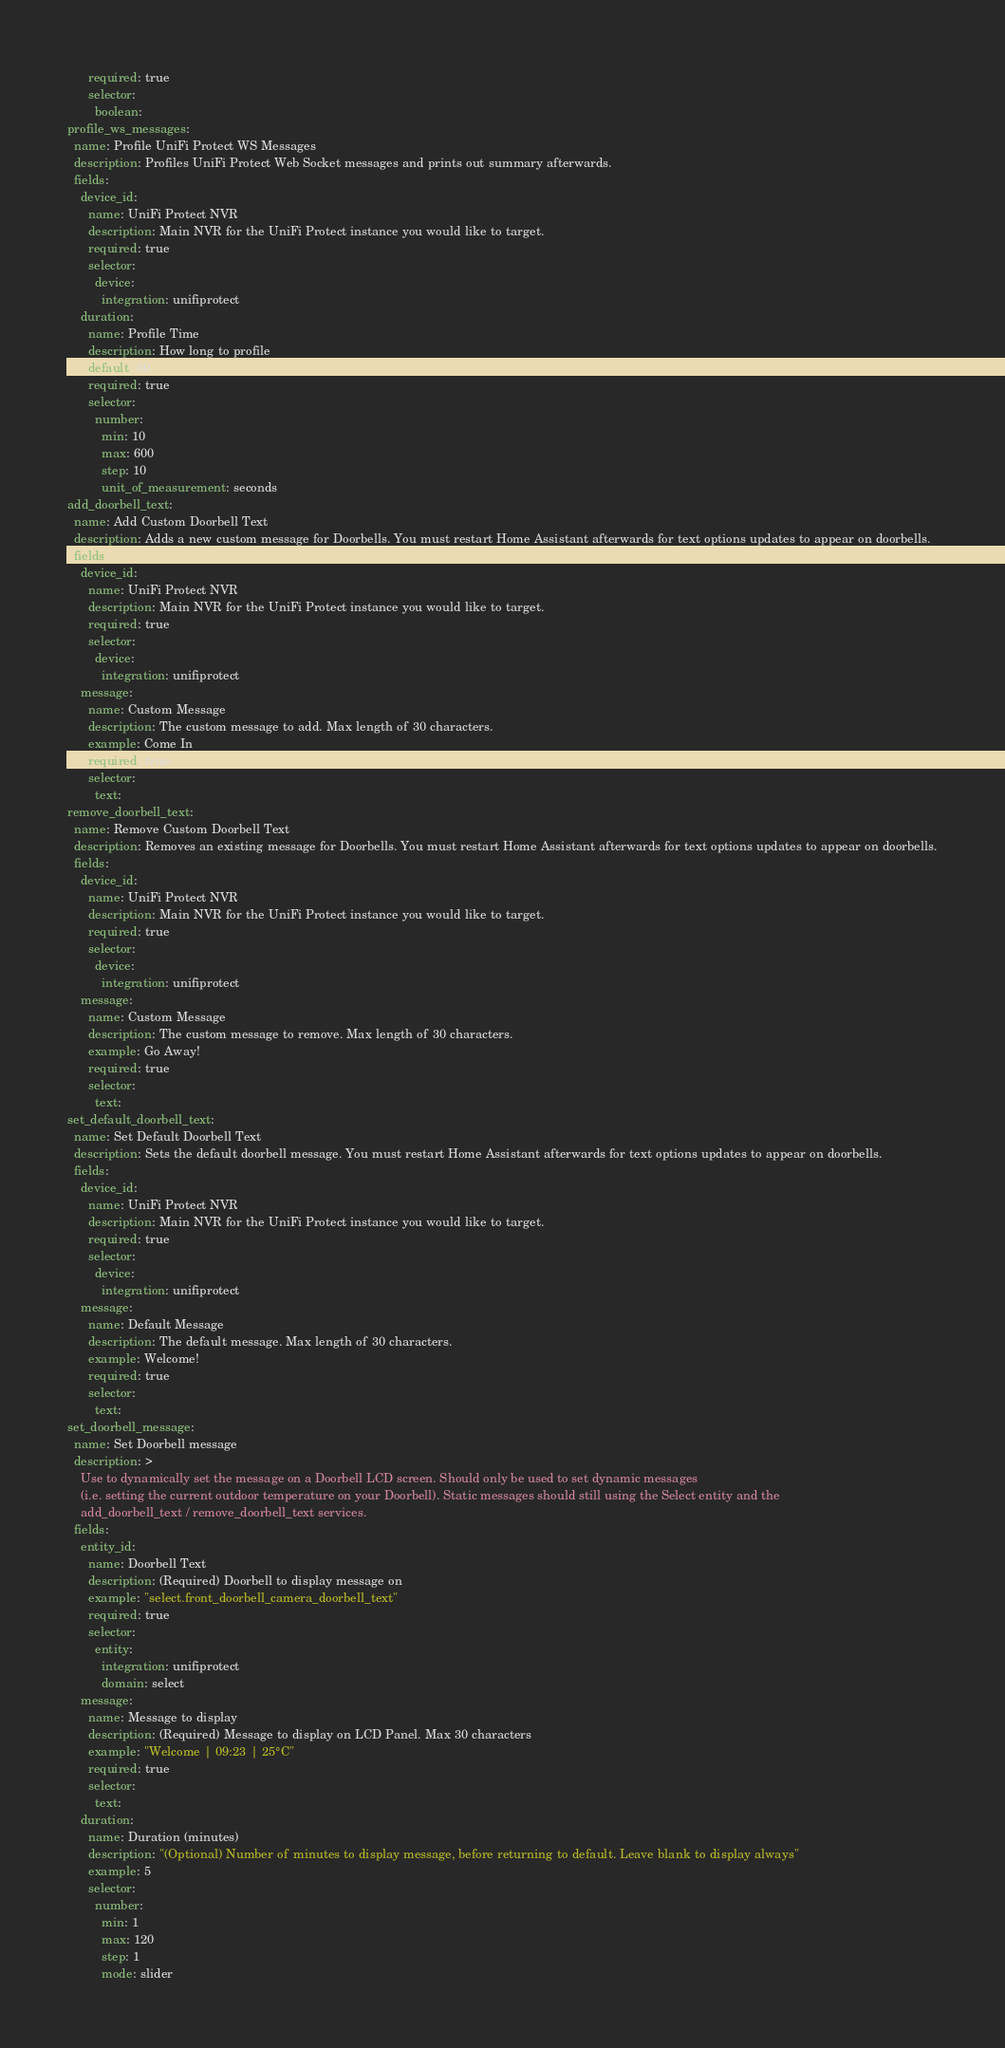<code> <loc_0><loc_0><loc_500><loc_500><_YAML_>      required: true
      selector:
        boolean:
profile_ws_messages:
  name: Profile UniFi Protect WS Messages
  description: Profiles UniFi Protect Web Socket messages and prints out summary afterwards.
  fields:
    device_id:
      name: UniFi Protect NVR
      description: Main NVR for the UniFi Protect instance you would like to target.
      required: true
      selector:
        device:
          integration: unifiprotect
    duration:
      name: Profile Time
      description: How long to profile
      default: 60
      required: true
      selector:
        number:
          min: 10
          max: 600
          step: 10
          unit_of_measurement: seconds
add_doorbell_text:
  name: Add Custom Doorbell Text
  description: Adds a new custom message for Doorbells. You must restart Home Assistant afterwards for text options updates to appear on doorbells.
  fields:
    device_id:
      name: UniFi Protect NVR
      description: Main NVR for the UniFi Protect instance you would like to target.
      required: true
      selector:
        device:
          integration: unifiprotect
    message:
      name: Custom Message
      description: The custom message to add. Max length of 30 characters.
      example: Come In
      required: true
      selector:
        text:
remove_doorbell_text:
  name: Remove Custom Doorbell Text
  description: Removes an existing message for Doorbells. You must restart Home Assistant afterwards for text options updates to appear on doorbells.
  fields:
    device_id:
      name: UniFi Protect NVR
      description: Main NVR for the UniFi Protect instance you would like to target.
      required: true
      selector:
        device:
          integration: unifiprotect
    message:
      name: Custom Message
      description: The custom message to remove. Max length of 30 characters.
      example: Go Away!
      required: true
      selector:
        text:
set_default_doorbell_text:
  name: Set Default Doorbell Text
  description: Sets the default doorbell message. You must restart Home Assistant afterwards for text options updates to appear on doorbells.
  fields:
    device_id:
      name: UniFi Protect NVR
      description: Main NVR for the UniFi Protect instance you would like to target.
      required: true
      selector:
        device:
          integration: unifiprotect
    message:
      name: Default Message
      description: The default message. Max length of 30 characters.
      example: Welcome!
      required: true
      selector:
        text:
set_doorbell_message:
  name: Set Doorbell message
  description: >
    Use to dynamically set the message on a Doorbell LCD screen. Should only be used to set dynamic messages
    (i.e. setting the current outdoor temperature on your Doorbell). Static messages should still using the Select entity and the
    add_doorbell_text / remove_doorbell_text services.
  fields:
    entity_id:
      name: Doorbell Text
      description: (Required) Doorbell to display message on
      example: "select.front_doorbell_camera_doorbell_text"
      required: true
      selector:
        entity:
          integration: unifiprotect
          domain: select
    message:
      name: Message to display
      description: (Required) Message to display on LCD Panel. Max 30 characters
      example: "Welcome | 09:23 | 25°C"
      required: true
      selector:
        text:
    duration:
      name: Duration (minutes)
      description: "(Optional) Number of minutes to display message, before returning to default. Leave blank to display always"
      example: 5
      selector:
        number:
          min: 1
          max: 120
          step: 1
          mode: slider
</code> 